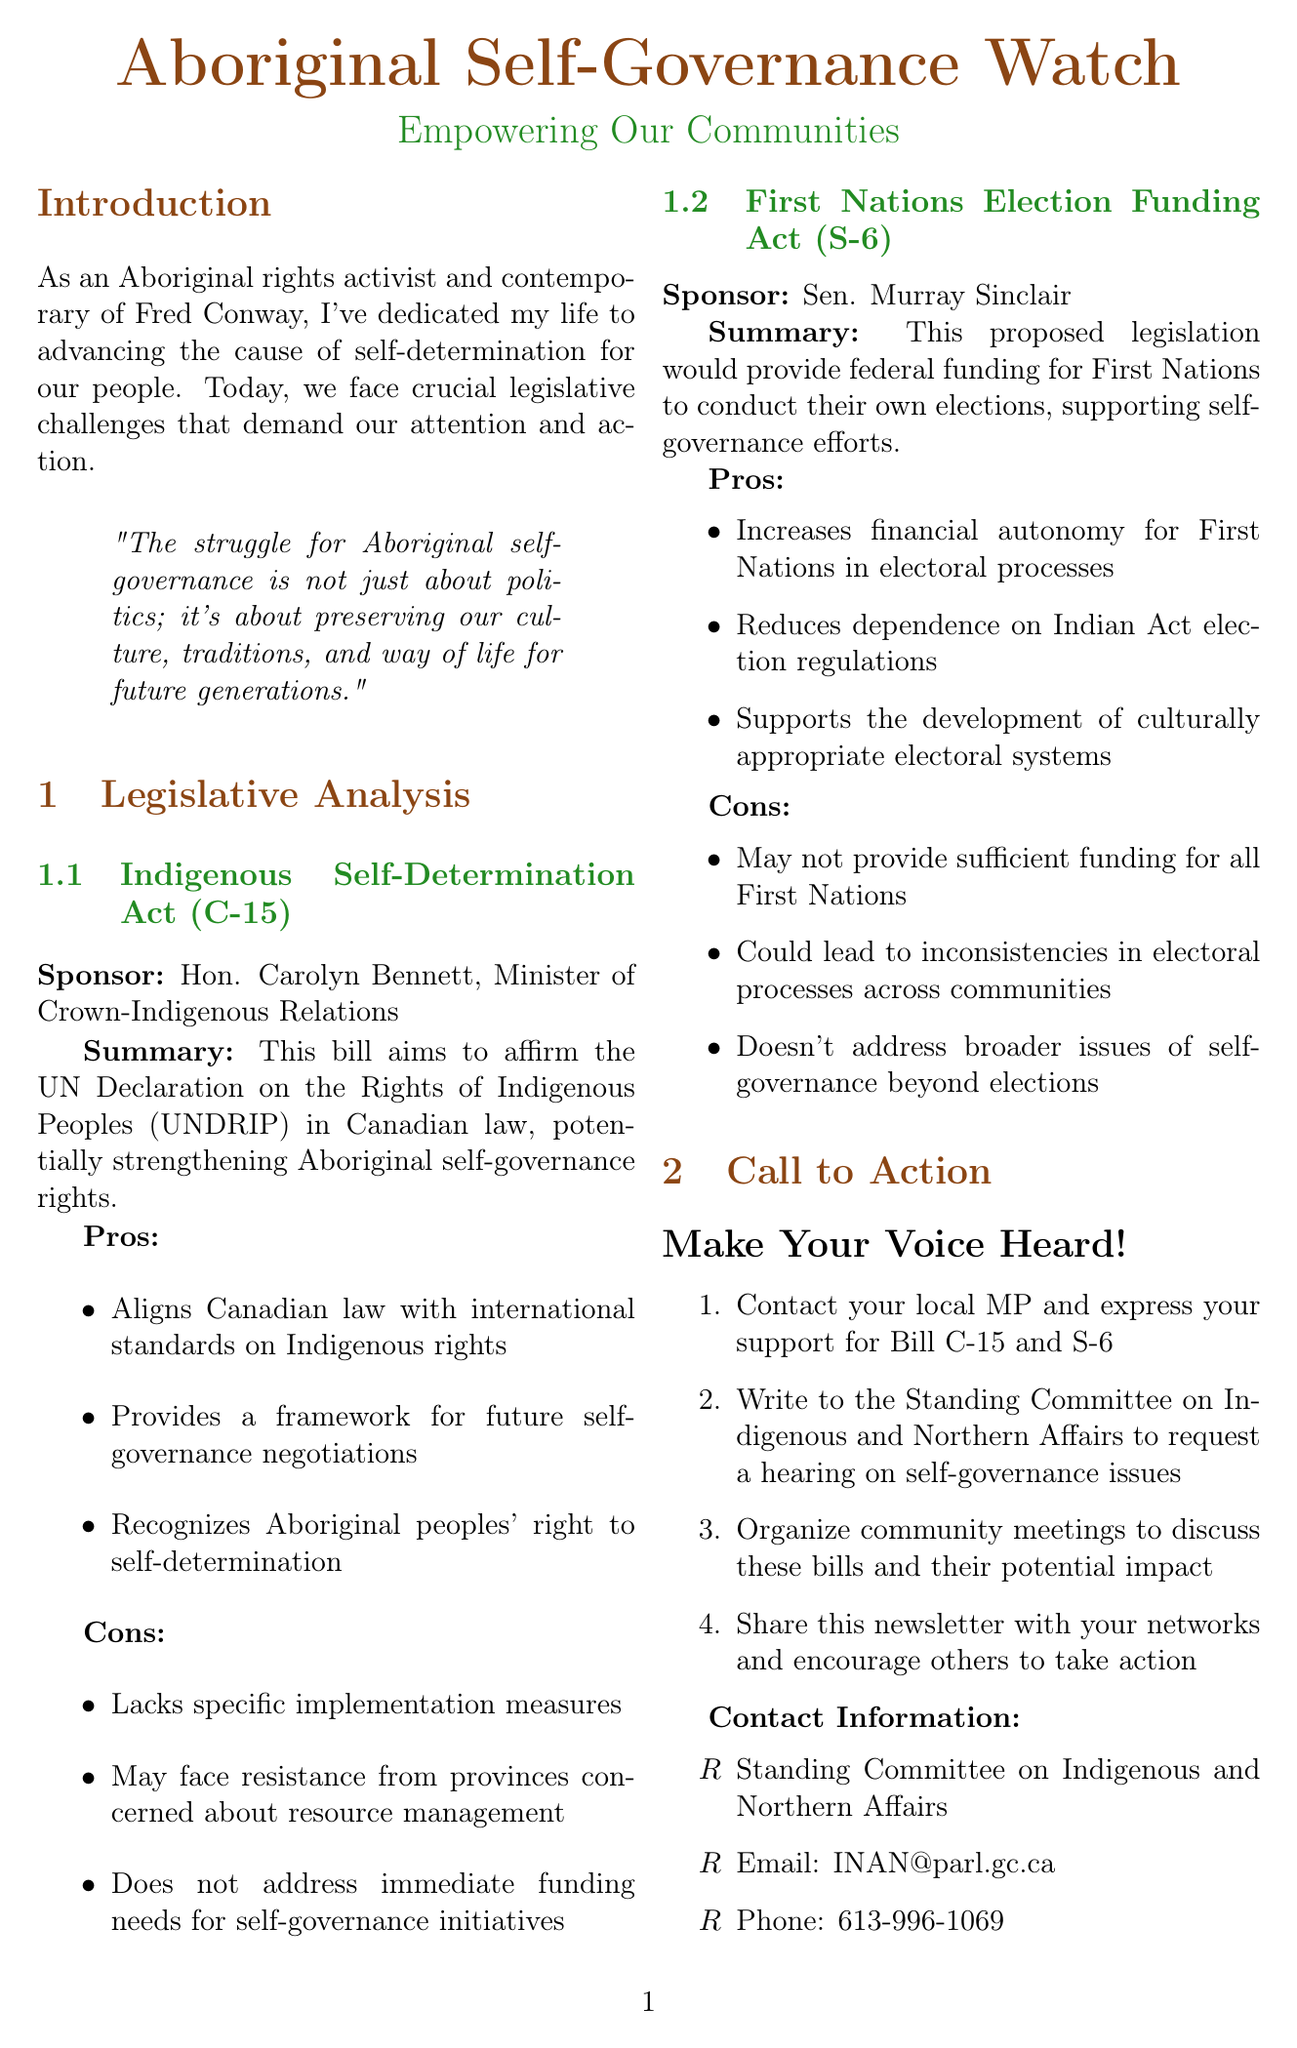What is the title of the newsletter? The title is stated prominently at the beginning of the document.
Answer: Aboriginal Self-Governance Watch: Empowering Our Communities Who sponsors the Indigenous Self-Determination Act? The document lists the sponsor of the bill directly.
Answer: Hon. Carolyn Bennett, Minister of Crown-Indigenous Relations What is one of the pros of the First Nations Election Funding Act? The document lists various pros for this bill, emphasizing its benefits.
Answer: Increases financial autonomy for First Nations in electoral processes What year was the constitutional recognition of Aboriginal rights established in Section 35? The document includes key events with their respective years.
Answer: 1982 How many steps are in the call to action? The call to action section enumerates specific actions for the reader.
Answer: Four 